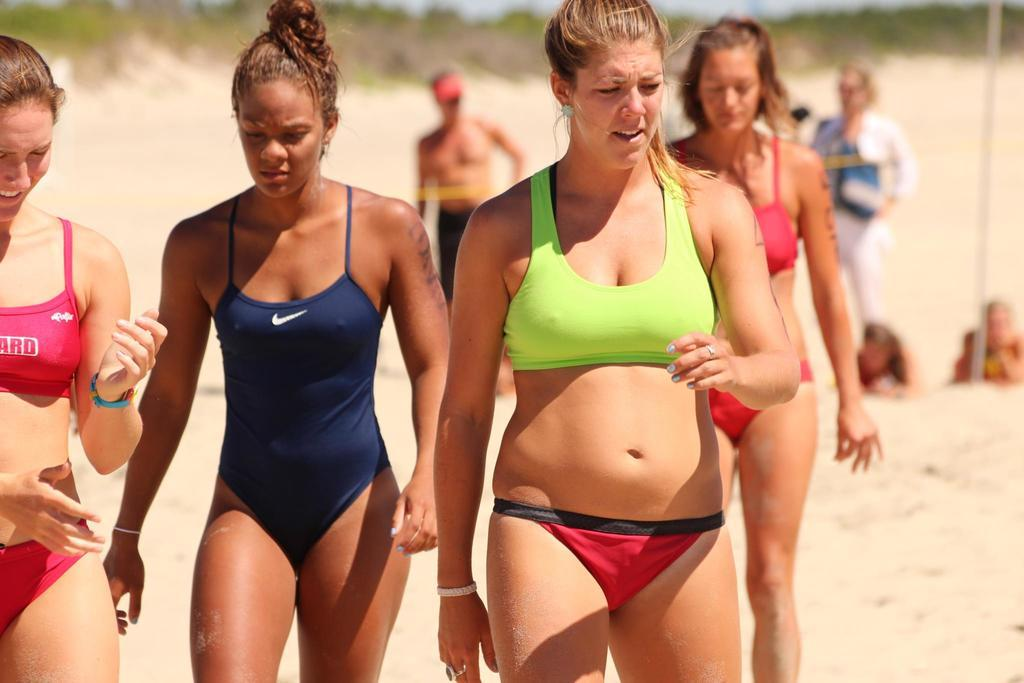Who or what can be seen in the image? There are people in the image. What are the people doing in the image? The people are walking on the sand. Can you describe the background of the image? The background of the image is blurry. What type of wristwatch can be seen on the sheep in the image? There are no sheep or wristwatches present in the image. 